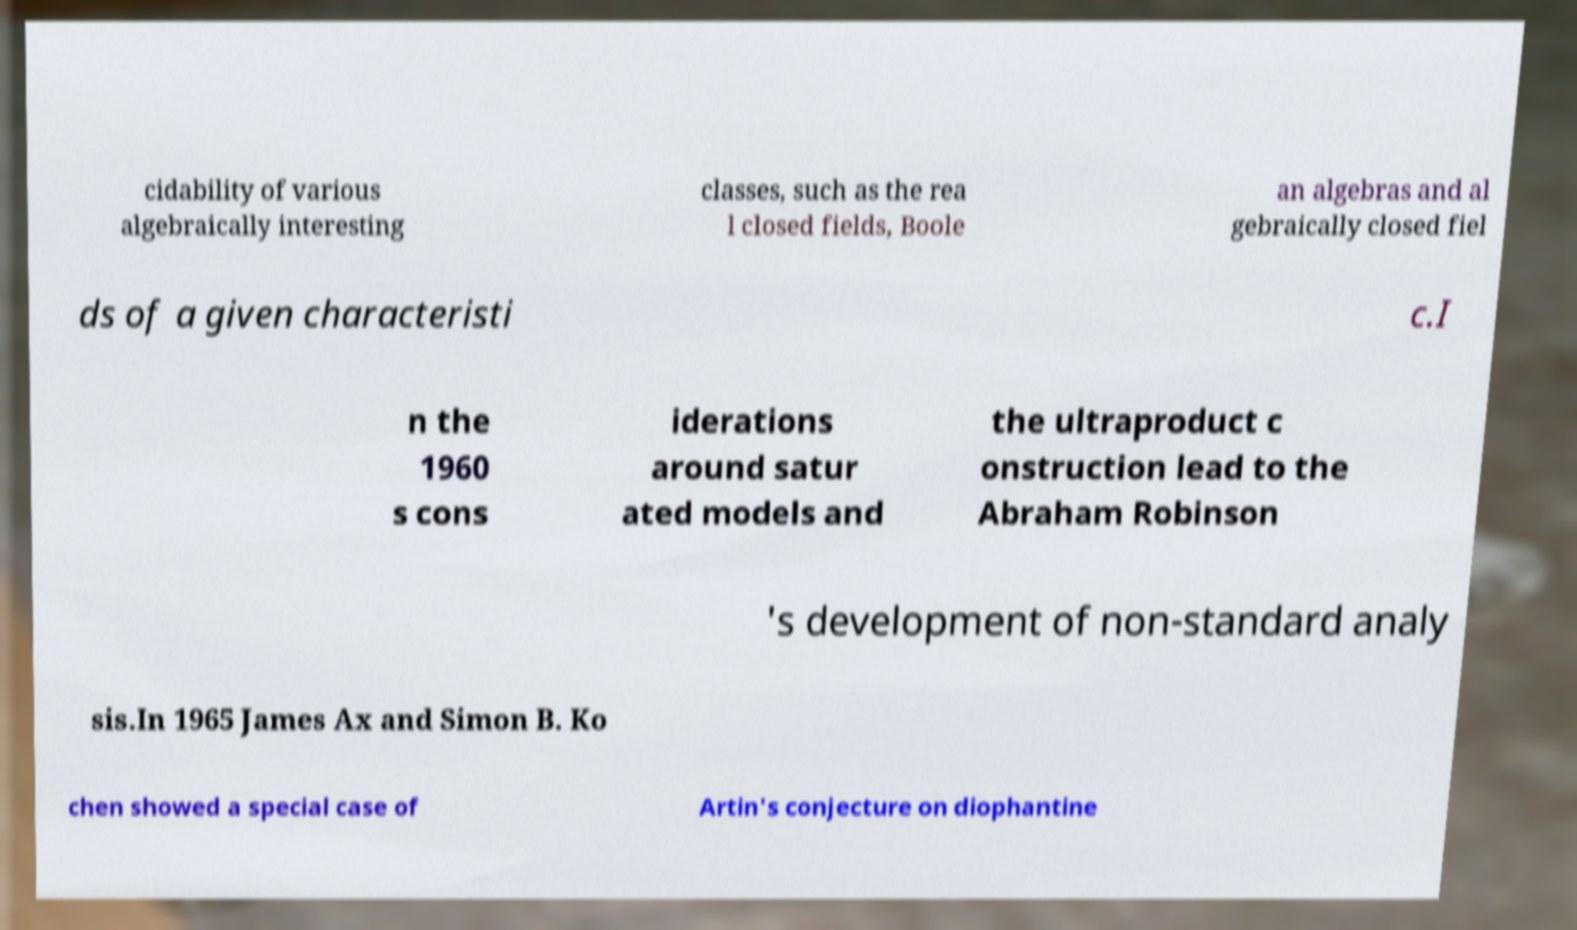What messages or text are displayed in this image? I need them in a readable, typed format. cidability of various algebraically interesting classes, such as the rea l closed fields, Boole an algebras and al gebraically closed fiel ds of a given characteristi c.I n the 1960 s cons iderations around satur ated models and the ultraproduct c onstruction lead to the Abraham Robinson 's development of non-standard analy sis.In 1965 James Ax and Simon B. Ko chen showed a special case of Artin's conjecture on diophantine 